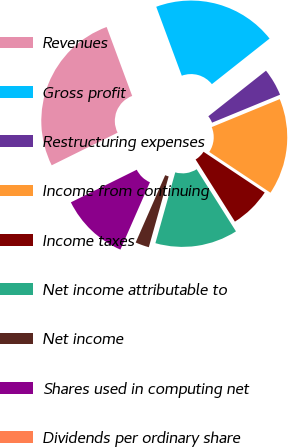<chart> <loc_0><loc_0><loc_500><loc_500><pie_chart><fcel>Revenues<fcel>Gross profit<fcel>Restructuring expenses<fcel>Income from continuing<fcel>Income taxes<fcel>Net income attributable to<fcel>Net income<fcel>Shares used in computing net<fcel>Dividends per ordinary share<nl><fcel>26.67%<fcel>20.0%<fcel>4.44%<fcel>15.56%<fcel>6.67%<fcel>13.33%<fcel>2.22%<fcel>11.11%<fcel>0.0%<nl></chart> 